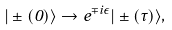Convert formula to latex. <formula><loc_0><loc_0><loc_500><loc_500>| \pm ( 0 ) \rangle \rightarrow e ^ { \mp i \epsilon } | \pm ( \tau ) \rangle ,</formula> 